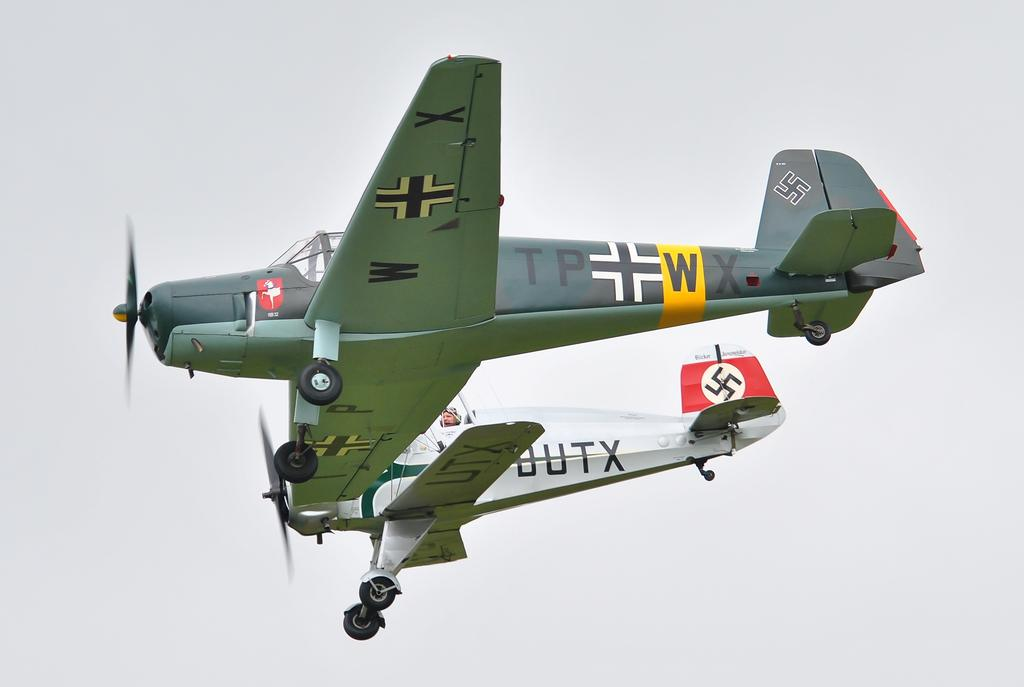<image>
Write a terse but informative summary of the picture. The letters UTX are painted on the underside of an airplane wing. 